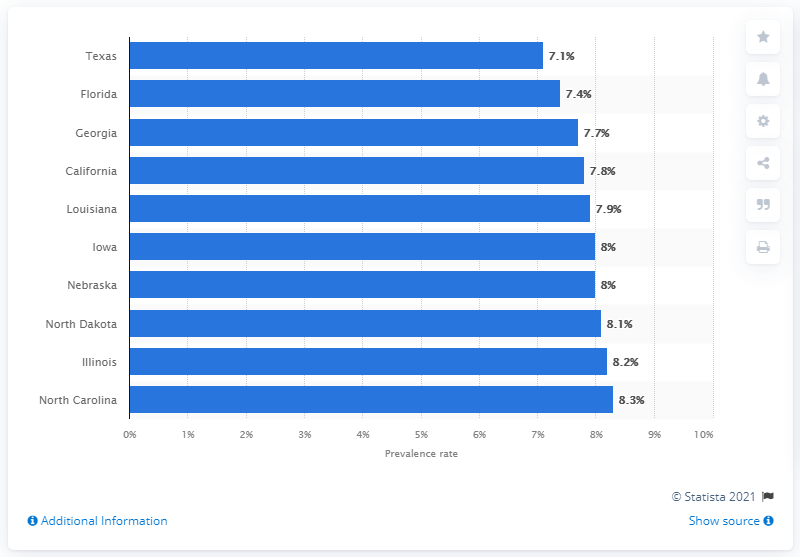Specify some key components in this picture. According to the data, Texas had the lowest current asthma prevalence among adults in the United States. 